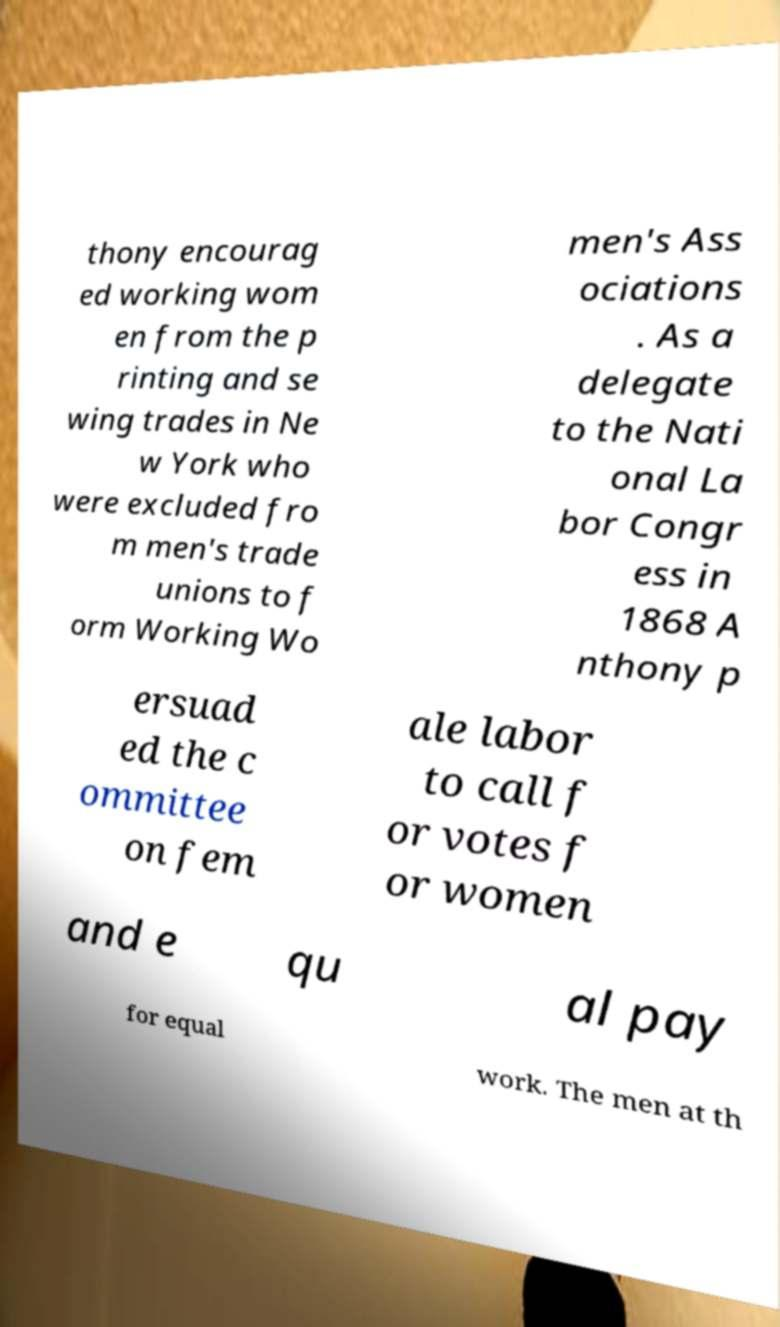There's text embedded in this image that I need extracted. Can you transcribe it verbatim? thony encourag ed working wom en from the p rinting and se wing trades in Ne w York who were excluded fro m men's trade unions to f orm Working Wo men's Ass ociations . As a delegate to the Nati onal La bor Congr ess in 1868 A nthony p ersuad ed the c ommittee on fem ale labor to call f or votes f or women and e qu al pay for equal work. The men at th 